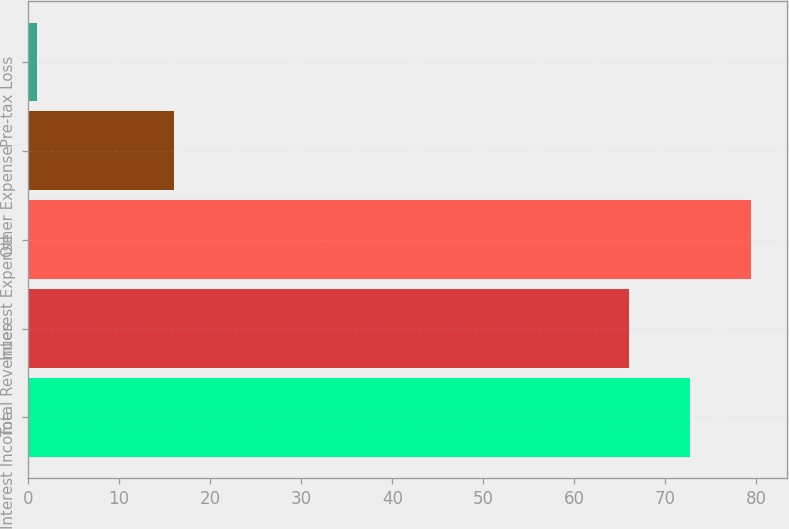Convert chart to OTSL. <chart><loc_0><loc_0><loc_500><loc_500><bar_chart><fcel>Interest Income<fcel>Total Revenues<fcel>Interest Expense<fcel>Other Expense<fcel>Pre-tax Loss<nl><fcel>72.7<fcel>66<fcel>79.4<fcel>16<fcel>1<nl></chart> 